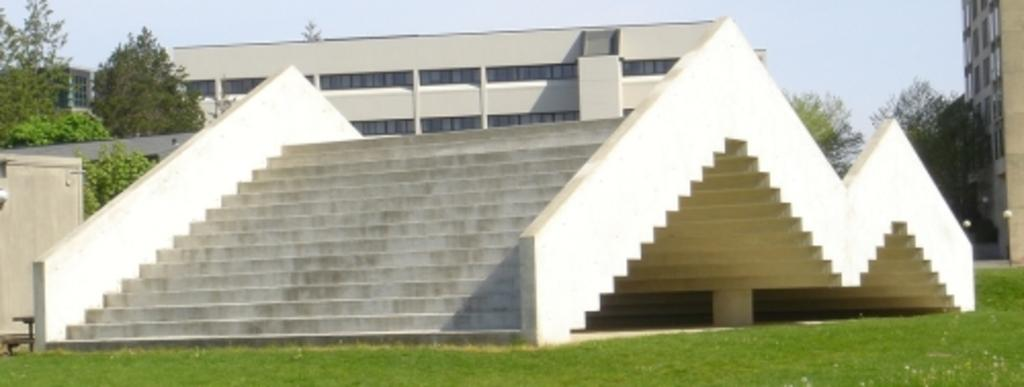What type of structure can be seen in the image? There are staircases, a house, and buildings in the image. What type of vegetation is present in the image? There is grass and trees in the image. What type of artificial lighting is present in the image? There are light poles in the image. What can be seen in the background of the image? The sky is visible in the background of the image. What type of chain is being used to produce the care in the image? There is no chain, produce, or care present in the image. 